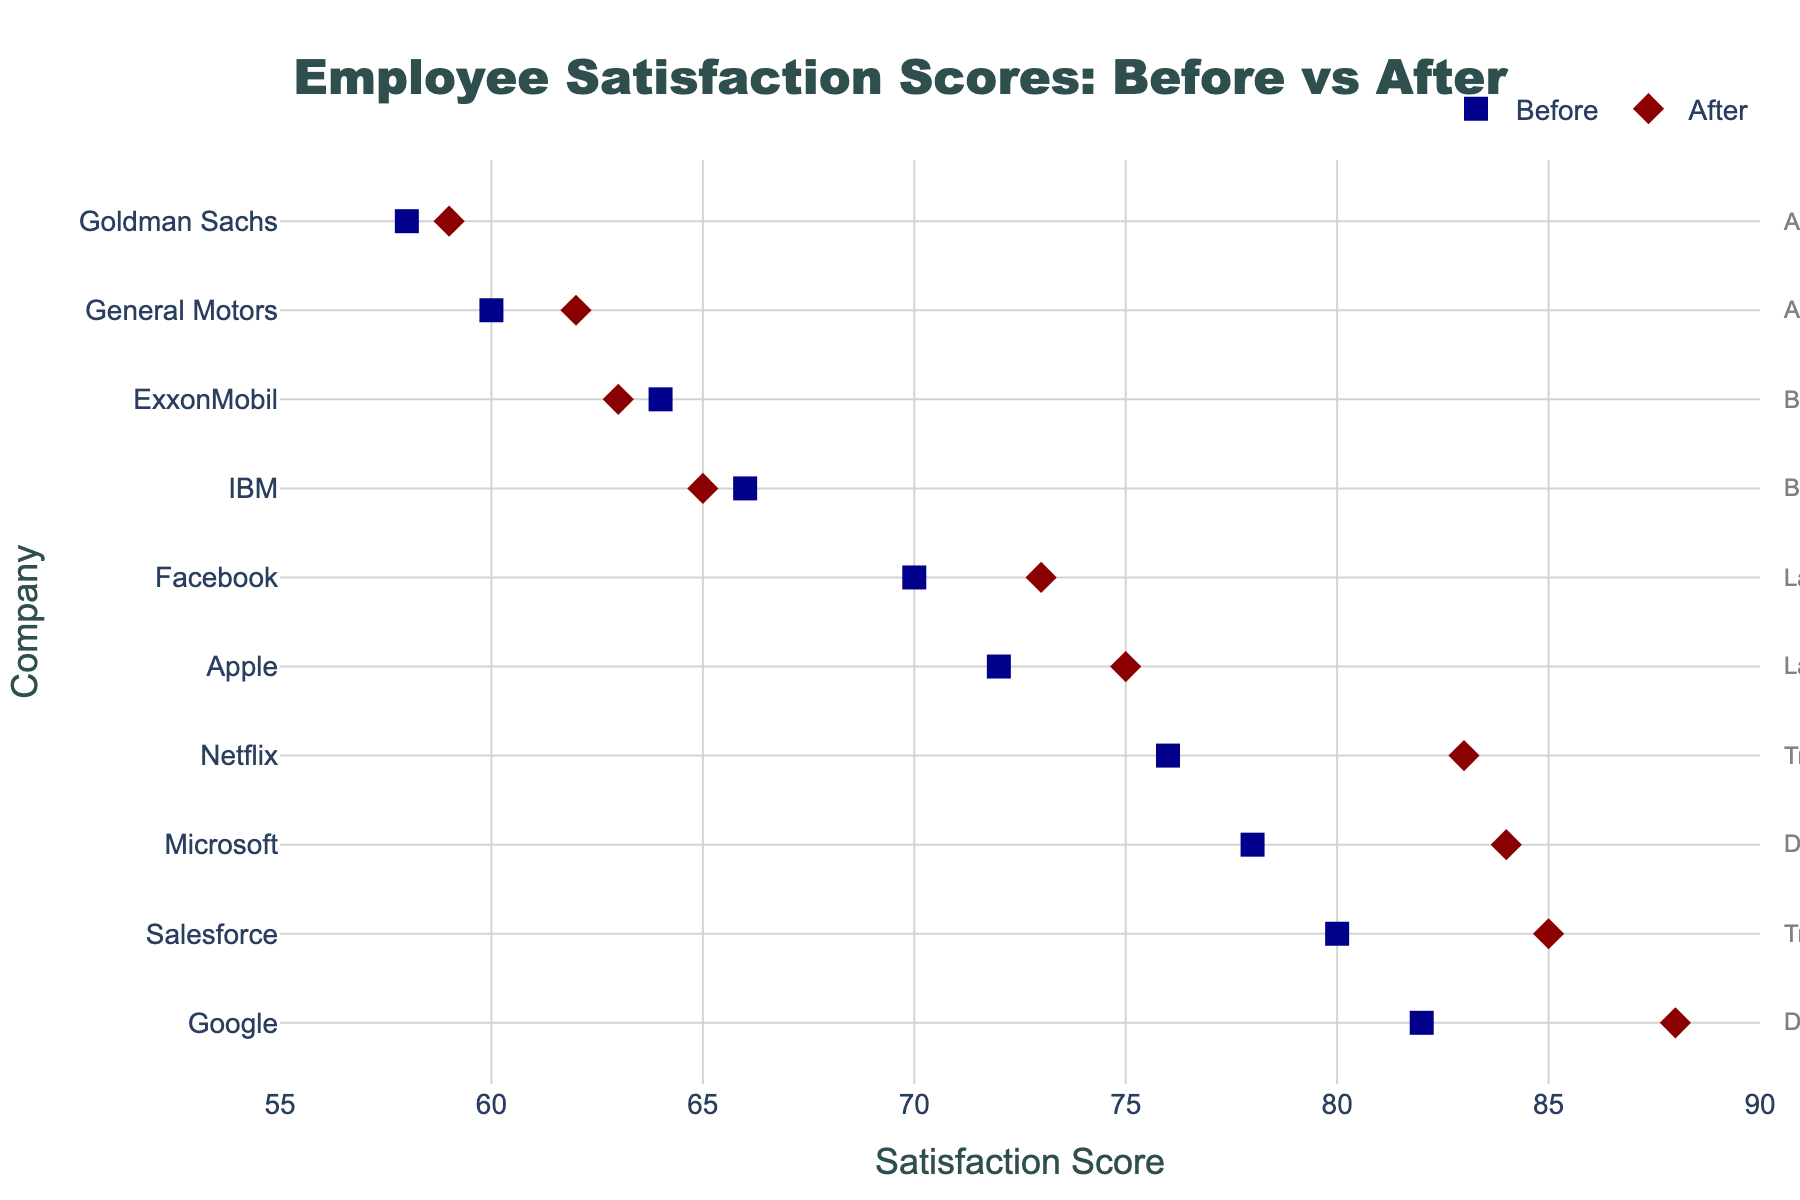What's the title of the plot? The title is displayed at the top center of the plot in large, bold font: "Employee Satisfaction Scores: Before vs After".
Answer: Employee Satisfaction Scores: Before vs After What is the range of the satisfaction scores on the x-axis? The x-axis range shows satisfaction scores starting from 55 to 90, which can be identified by the axis ticks and labels.
Answer: 55 to 90 How many companies are represented in the plot? Each company is represented by a pair of markers and a horizontal line. There are 10 companies listed on the y-axis.
Answer: 10 Which company has the highest 'After Satisfaction Score'? By looking at the red diamond markers along the x-axis, Google has the highest 'After Satisfaction Score' of 88.
Answer: Google What is the difference in the 'Before' and 'After' scores for Microsoft? Microsoft's markers are located at 78 for the 'Before' score and 84 for the 'After' score. The difference is 84 - 78 = 6.
Answer: 6 Which management style has the overall highest 'Before Satisfaction Scores'? The 'Before Satisfaction Scores' range from 60 to 82; Democratic (Google, Microsoft) is at the higher end, with Google at 82.
Answer: Democratic What is the average 'After Satisfaction Score' for the companies with a Democratic management style? The Democratic companies, Google and Microsoft, have 'After Scores' of 88 and 84 respectively. The average is (88 + 84) / 2 = 86.
Answer: 86 Compare the satisfaction score change for companies with a Bureaucratic management style. Is it increasing or decreasing? IBM and ExxonMobil are Bureaucratic companies. Both show a decrease, with IBM from 66 to 65 and ExxonMobil from 64 to 63.
Answer: Decreasing Which company saw the largest increase in 'Satisfaction Score'? By comparing the differences, Netflix shows a notable increase from 76 to 83, which is an increase of 7.
Answer: Netflix If a company's 'After Satisfaction Score' is above 80, what management style might it belong to? The companies with 'After Scores' above 80 are Google (88), Microsoft (84), Salesforce (85), and Netflix (83). These correspond to Democratic and Transformational styles.
Answer: Democratic or Transformational 